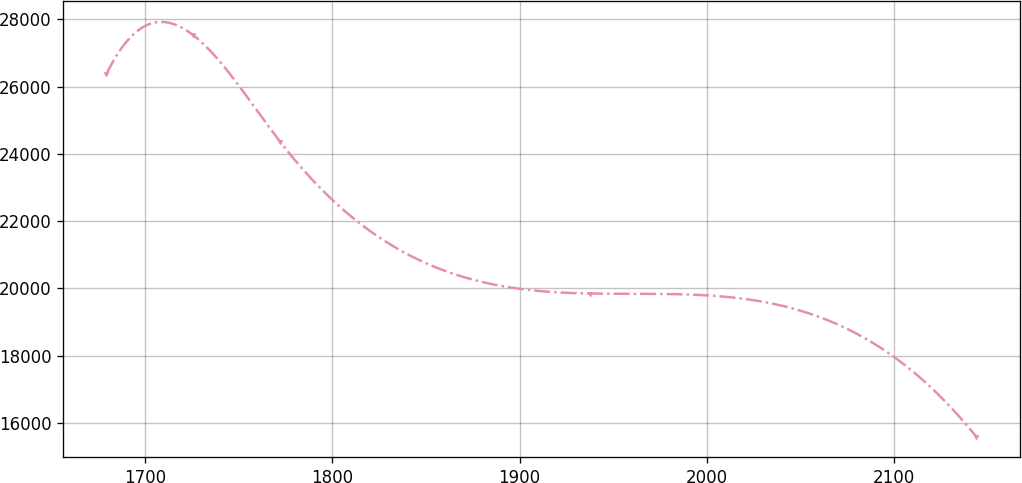<chart> <loc_0><loc_0><loc_500><loc_500><line_chart><ecel><fcel>Unnamed: 1<nl><fcel>1679.33<fcel>26376.1<nl><fcel>1725.79<fcel>27530.4<nl><fcel>1772.25<fcel>24352.6<nl><fcel>1937.87<fcel>19846.1<nl><fcel>2143.95<fcel>15588<nl></chart> 